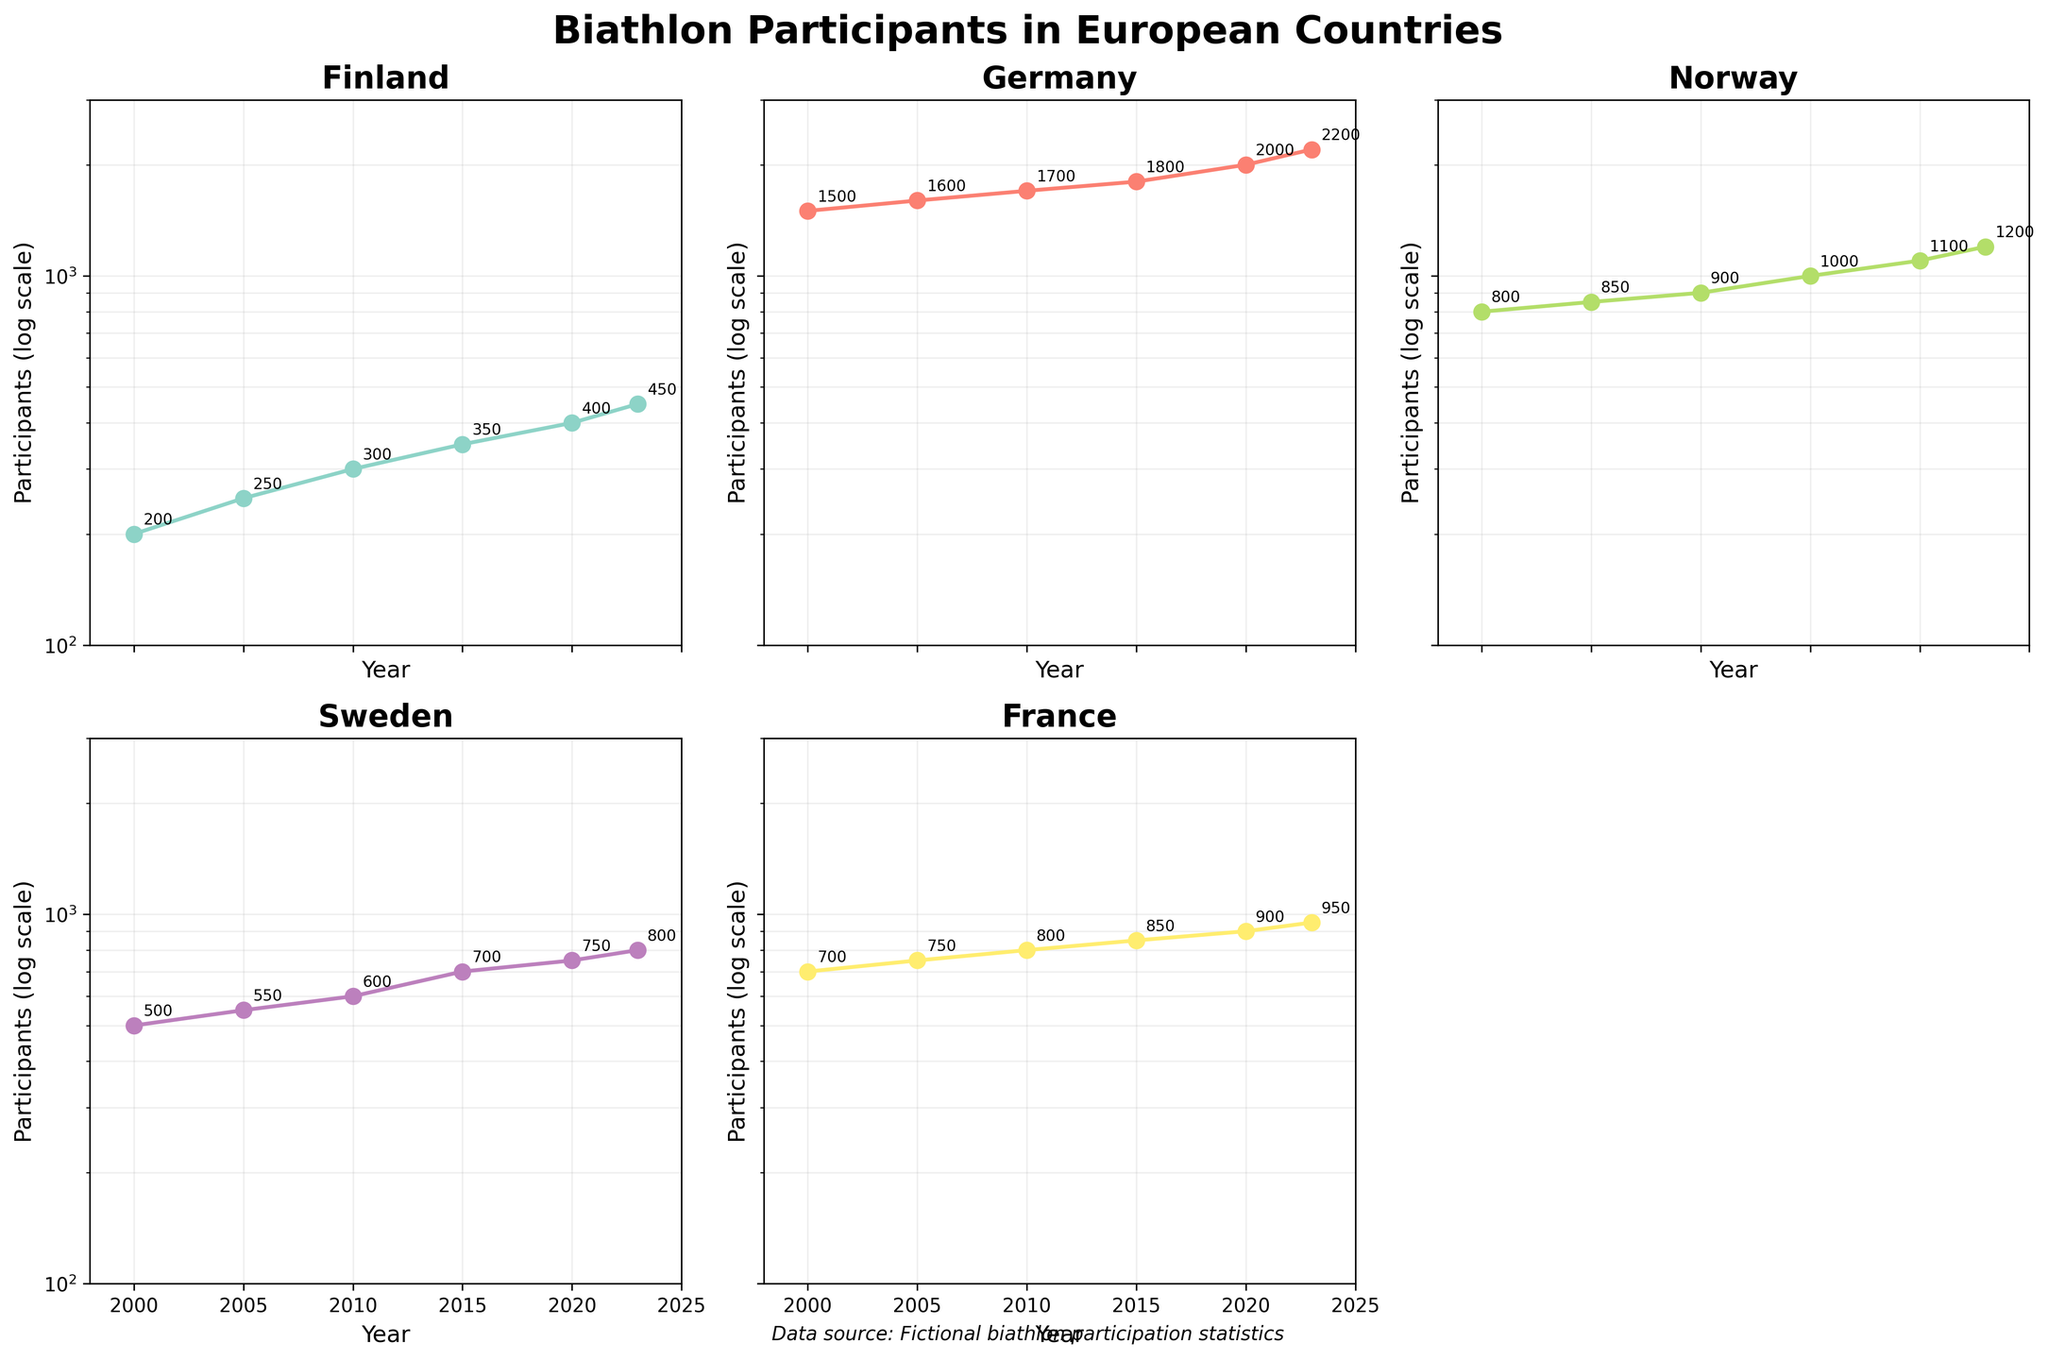What is the title of the figure? The title of the figure is placed at the top center and it states the main topic of the figure. It can be found in a larger font size compared to other text for emphasis.
Answer: Biathlon Participants in European Countries How many participants were there in Finland in 2020? This specific information can be found by looking at the Finland subplot and identifying the data point for the year 2020. The value is annotated near the data point.
Answer: 400 Which country had the highest number of participants in 2000? By examining the subplots for all countries and looking at the data points for the year 2000, one can identify that Germany had the highest number of participants in that year.
Answer: Germany By how much did the number of participants in Finland increase from 2000 to 2023? Look at the Finland subplot, identify the participants for 2000 and 2023, and calculate the difference: 450 (2023) - 200 (2000).
Answer: 250 Which country experienced the largest increase in participants between 2005 and 2023? For each country, find the difference in the number of participants between 2005 and 2023, and then compare these values. Germany had an increase of 600 participants, from 1600 to 2200.
Answer: Germany Did any country have a decrease in the number of participants over the years shown? By checking each subplot and ensuring that the number of participants increases over the years for all countries, it can be seen that none of the countries experienced a decrease.
Answer: No What is the trend in the number of biathlon participants in Norway from 2000 to 2023? By observing the Norway subplot, it's clear that the number of participants consistently increased from 800 in 2000 to 1200 in 2023.
Answer: Increasing Compare the number of participants in Sweden and France in the year 2023. Which country had more participants? Identify the data points for 2023 in the subplots for Sweden and France. Sweden had 800 participants, and France had 950 participants in that year.
Answer: France In which year did Germany have 2000 participants? Examine the Germany subplot and locate the data annotation corresponding to 2000 participants. This occurs in the year 2020.
Answer: 2020 